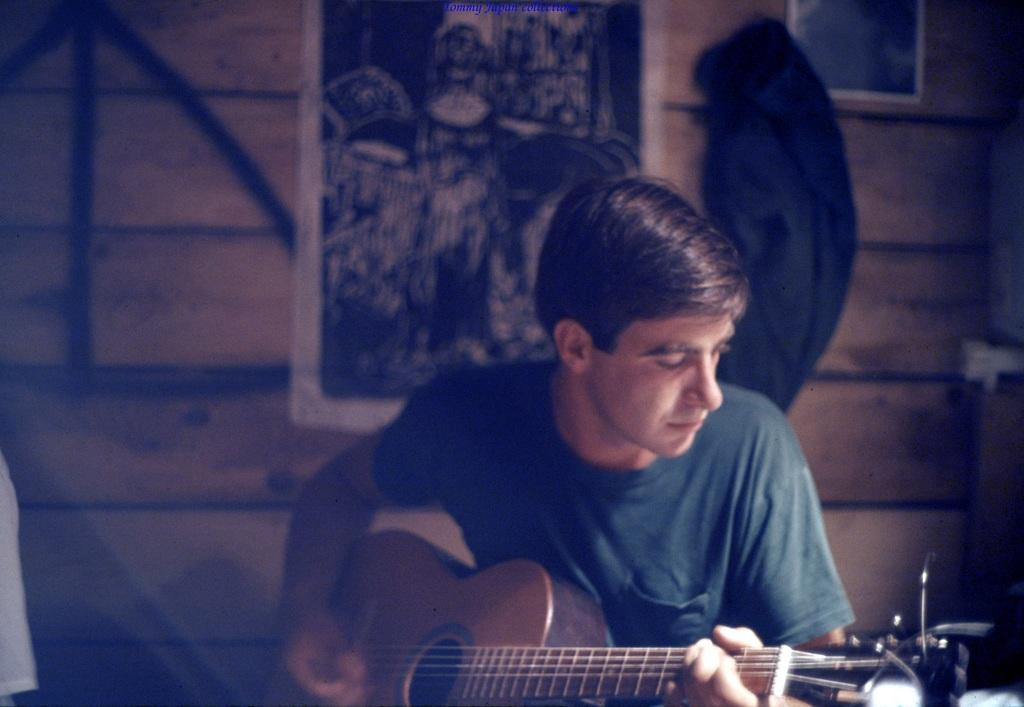What is the man in the image doing? The man is playing the guitar in the image. What can be seen in the background of the image? There is a wall in the background of the image. Is there anything on the wall in the image? Yes, there is a poster on the wall. How many mittens are visible in the image? There are no mittens present in the image. What type of party is being held in the image? There is no party depicted in the image; it features a man playing the guitar with a poster on the wall in the background. 